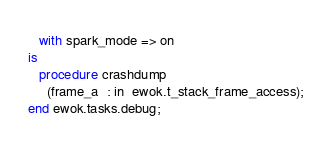Convert code to text. <code><loc_0><loc_0><loc_500><loc_500><_Ada_>   with spark_mode => on
is
   procedure crashdump
     (frame_a  : in  ewok.t_stack_frame_access);
end ewok.tasks.debug;
</code> 